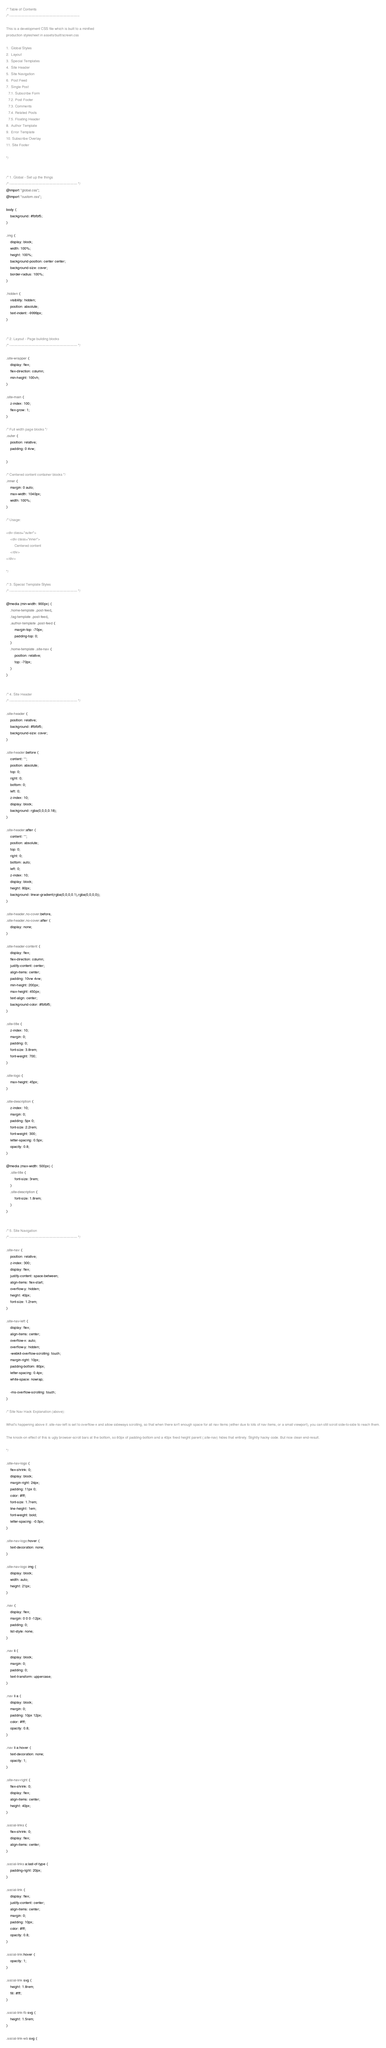<code> <loc_0><loc_0><loc_500><loc_500><_CSS_>/* Table of Contents
/* ------------------------------------------------------------

This is a development CSS file which is built to a minified
production stylesheet in assets/built/screen.css

1.  Global Styles
2.  Layout
3.  Special Templates
4.  Site Header
5.  Site Navigation
6.  Post Feed
7.  Single Post
  7.1. Subscribe Form
  7.2. Post Footer
  7.3. Comments
  7.4. Related Posts
  7.5. Floating Header
8.  Author Template
9.  Error Template
10. Subscribe Overlay
11. Site Footer

*/


/* 1. Global - Set up the things
/* ---------------------------------------------------------- */
@import "global.css";
@import "custom.css";

body {
    background: #fbfbf5;
}

.img {
    display: block;
    width: 100%;
    height: 100%;
    background-position: center center;
    background-size: cover;
    border-radius: 100%;
}

.hidden {
    visibility: hidden;
    position: absolute;
    text-indent: -9999px;
}


/* 2. Layout - Page building blocks
/* ---------------------------------------------------------- */

.site-wrapper {
    display: flex;
    flex-direction: column;
    min-height: 100vh;
}

.site-main {
    z-index: 100;
    flex-grow: 1;
}

/* Full width page blocks */
.outer {
    position: relative;
    padding: 0 4vw;

}

/* Centered content container blocks */
.inner {
    margin: 0 auto;
    max-width: 1040px;
    width: 100%;
}

/* Usage:

<div class="outer">
    <div class="inner">
        Centered content
    </div>
</div>

*/

/* 3. Special Template Styles
/* ---------------------------------------------------------- */

@media (min-width: 900px) {
    .home-template .post-feed,
    .tag-template .post-feed,
    .author-template .post-feed {
        margin-top: -70px;
        padding-top: 0;
    }
    .home-template .site-nav {
        position: relative;
        top: -70px;
    }
}


/* 4. Site Header
/* ---------------------------------------------------------- */

.site-header {
    position: relative;
    background: #fbfbf5;
    background-size: cover;
}

.site-header:before {
    content: "";
    position: absolute;
    top: 0;
    right: 0;
    bottom: 0;
    left: 0;
    z-index: 10;
    display: block;
    background: rgba(0,0,0,0.18);
}

.site-header:after {
    content: "";
    position: absolute;
    top: 0;
    right: 0;
    bottom: auto;
    left: 0;
    z-index: 10;
    display: block;
    height: 80px;
    background: linear-gradient(rgba(0,0,0,0.1),rgba(0,0,0,0));
}

.site-header.no-cover:before,
.site-header.no-cover:after {
    display: none;
}

.site-header-content {
    display: flex;
    flex-direction: column;
    justify-content: center;
    align-items: center;
    padding: 10vw 4vw;
    min-height: 200px;
    max-height: 450px;
    text-align: center;
    background-color: #fbfbf5;
}

.site-title {
    z-index: 10;
    margin: 0;
    padding: 0;
    font-size: 3.8rem;
    font-weight: 700;
}

.site-logo {
    max-height: 45px;
}

.site-description {
    z-index: 10;
    margin: 0;
    padding: 5px 0;
    font-size: 2.2rem;
    font-weight: 300;
    letter-spacing: 0.5px;
    opacity: 0.8;
}

@media (max-width: 500px) {
    .site-title {
        font-size: 3rem;
    }
    .site-description {
        font-size: 1.8rem;
    }
}


/* 5. Site Navigation
/* ---------------------------------------------------------- */

.site-nav {
    position: relative;
    z-index: 300;
    display: flex;
    justify-content: space-between;
    align-items: flex-start;
    overflow-y: hidden;
    height: 40px;
    font-size: 1.2rem;
}

.site-nav-left {
    display: flex;
    align-items: center;
    overflow-x: auto;
    overflow-y: hidden;
    -webkit-overflow-scrolling: touch;
    margin-right: 10px;
    padding-bottom: 80px;
    letter-spacing: 0.4px;
    white-space: nowrap;

    -ms-overflow-scrolling: touch;
}

/* Site Nav Hack Explanation (above):

What's happening above it .site-nav-left is set to overflow-x and allow sideways scrolling, so that when there isn't enough space for all nav items (either due to lots of nav items, or a small viewport), you can still scroll side-to-side to reach them.

The knock-on effect of this is ugly browser-scroll bars at the bottom, so 80px of padding-bottom and a 40px fixed height parent (.site-nav) hides that entirely. Slightly hacky code. But nice clean end-result.

*/

.site-nav-logo {
    flex-shrink: 0;
    display: block;
    margin-right: 24px;
    padding: 11px 0;
    color: #fff;
    font-size: 1.7rem;
    line-height: 1em;
    font-weight: bold;
    letter-spacing: -0.5px;
}

.site-nav-logo:hover {
    text-decoration: none;
}

.site-nav-logo img {
    display: block;
    width: auto;
    height: 21px;
}

.nav {
    display: flex;
    margin: 0 0 0 -12px;
    padding: 0;
    list-style: none;
}

.nav li {
    display: block;
    margin: 0;
    padding: 0;
    text-transform: uppercase;
}

.nav li a {
    display: block;
    margin: 0;
    padding: 10px 12px;
    color: #fff;
    opacity: 0.8;
}

.nav li a:hover {
    text-decoration: none;
    opacity: 1;
}

.site-nav-right {
    flex-shrink: 0;
    display: flex;
    align-items: center;
    height: 40px;
}

.social-links {
    flex-shrink: 0;
    display: flex;
    align-items: center;
}

.social-links a:last-of-type {
    padding-right: 20px;
}

.social-link {
    display: flex;
    justify-content: center;
    align-items: center;
    margin: 0;
    padding: 10px;
    color: #fff;
    opacity: 0.8;
}

.social-link:hover {
    opacity: 1;
}

.social-link svg {
    height: 1.8rem;
    fill: #fff;
}

.social-link-fb svg {
    height: 1.5rem;
}

.social-link-wb svg {</code> 